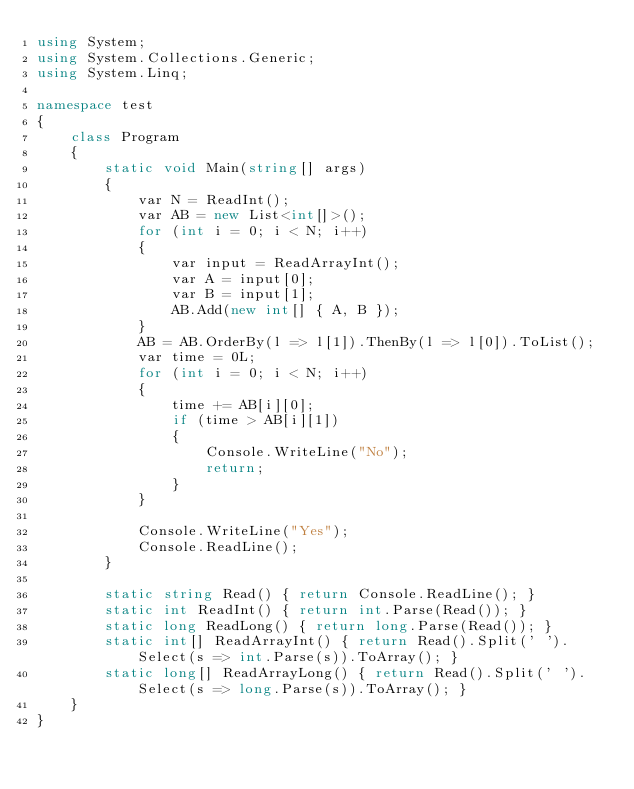Convert code to text. <code><loc_0><loc_0><loc_500><loc_500><_C#_>using System;
using System.Collections.Generic;
using System.Linq;

namespace test
{
    class Program
    {
        static void Main(string[] args)
        {
            var N = ReadInt();
            var AB = new List<int[]>();
            for (int i = 0; i < N; i++)
            {
                var input = ReadArrayInt();
                var A = input[0];
                var B = input[1];
                AB.Add(new int[] { A, B });
            }
            AB = AB.OrderBy(l => l[1]).ThenBy(l => l[0]).ToList();
            var time = 0L;
            for (int i = 0; i < N; i++)
            {
                time += AB[i][0];
                if (time > AB[i][1])
                {
                    Console.WriteLine("No");
                    return;
                }
            }
            
            Console.WriteLine("Yes");
            Console.ReadLine();
        }

        static string Read() { return Console.ReadLine(); }
        static int ReadInt() { return int.Parse(Read()); }
        static long ReadLong() { return long.Parse(Read()); }
        static int[] ReadArrayInt() { return Read().Split(' ').Select(s => int.Parse(s)).ToArray(); }
        static long[] ReadArrayLong() { return Read().Split(' ').Select(s => long.Parse(s)).ToArray(); }
    }
}</code> 